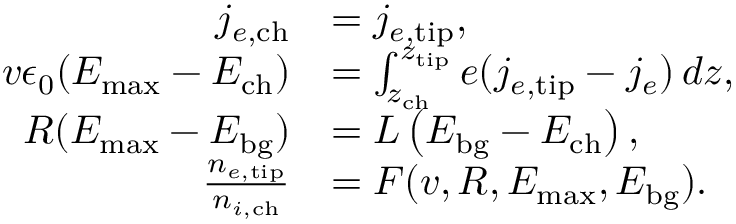<formula> <loc_0><loc_0><loc_500><loc_500>\begin{array} { r l } { j _ { e , c h } } & { = j _ { e , t i p } , } \\ { v \epsilon _ { 0 } ( E _ { \max } - E _ { c h } ) } & { = \int _ { z _ { c h } } ^ { z _ { t i p } } e ( j _ { e , t i p } - j _ { e } ) \, d z , } \\ { R ( E _ { \max } - E _ { b g } ) } & { = L \left ( E _ { b g } - E _ { c h } \right ) , } \\ { \frac { n _ { e , t i p } } { n _ { i , c h } } } & { = F ( v , R , E _ { \max } , E _ { b g } ) . } \end{array}</formula> 